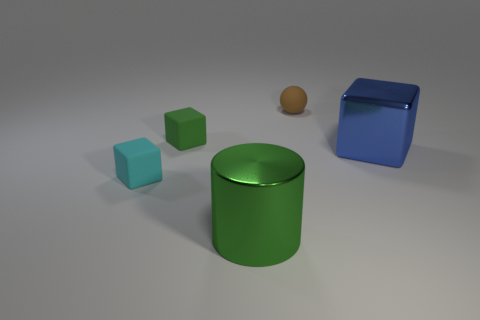Subtract all tiny rubber blocks. How many blocks are left? 1 Add 3 large brown cubes. How many objects exist? 8 Subtract 1 blocks. How many blocks are left? 2 Subtract all spheres. How many objects are left? 4 Subtract 1 green cubes. How many objects are left? 4 Subtract all cyan balls. Subtract all blue blocks. How many balls are left? 1 Subtract all big metal blocks. Subtract all cyan matte blocks. How many objects are left? 3 Add 4 large green metallic objects. How many large green metallic objects are left? 5 Add 1 small brown spheres. How many small brown spheres exist? 2 